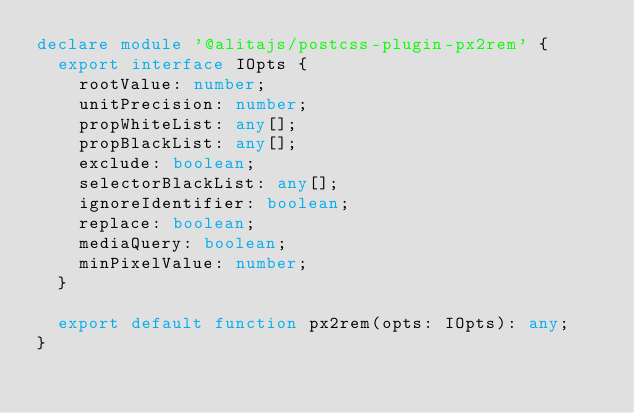<code> <loc_0><loc_0><loc_500><loc_500><_TypeScript_>declare module '@alitajs/postcss-plugin-px2rem' {
  export interface IOpts {
    rootValue: number;
    unitPrecision: number;
    propWhiteList: any[];
    propBlackList: any[];
    exclude: boolean;
    selectorBlackList: any[];
    ignoreIdentifier: boolean;
    replace: boolean;
    mediaQuery: boolean;
    minPixelValue: number;
  }

  export default function px2rem(opts: IOpts): any;
}
</code> 